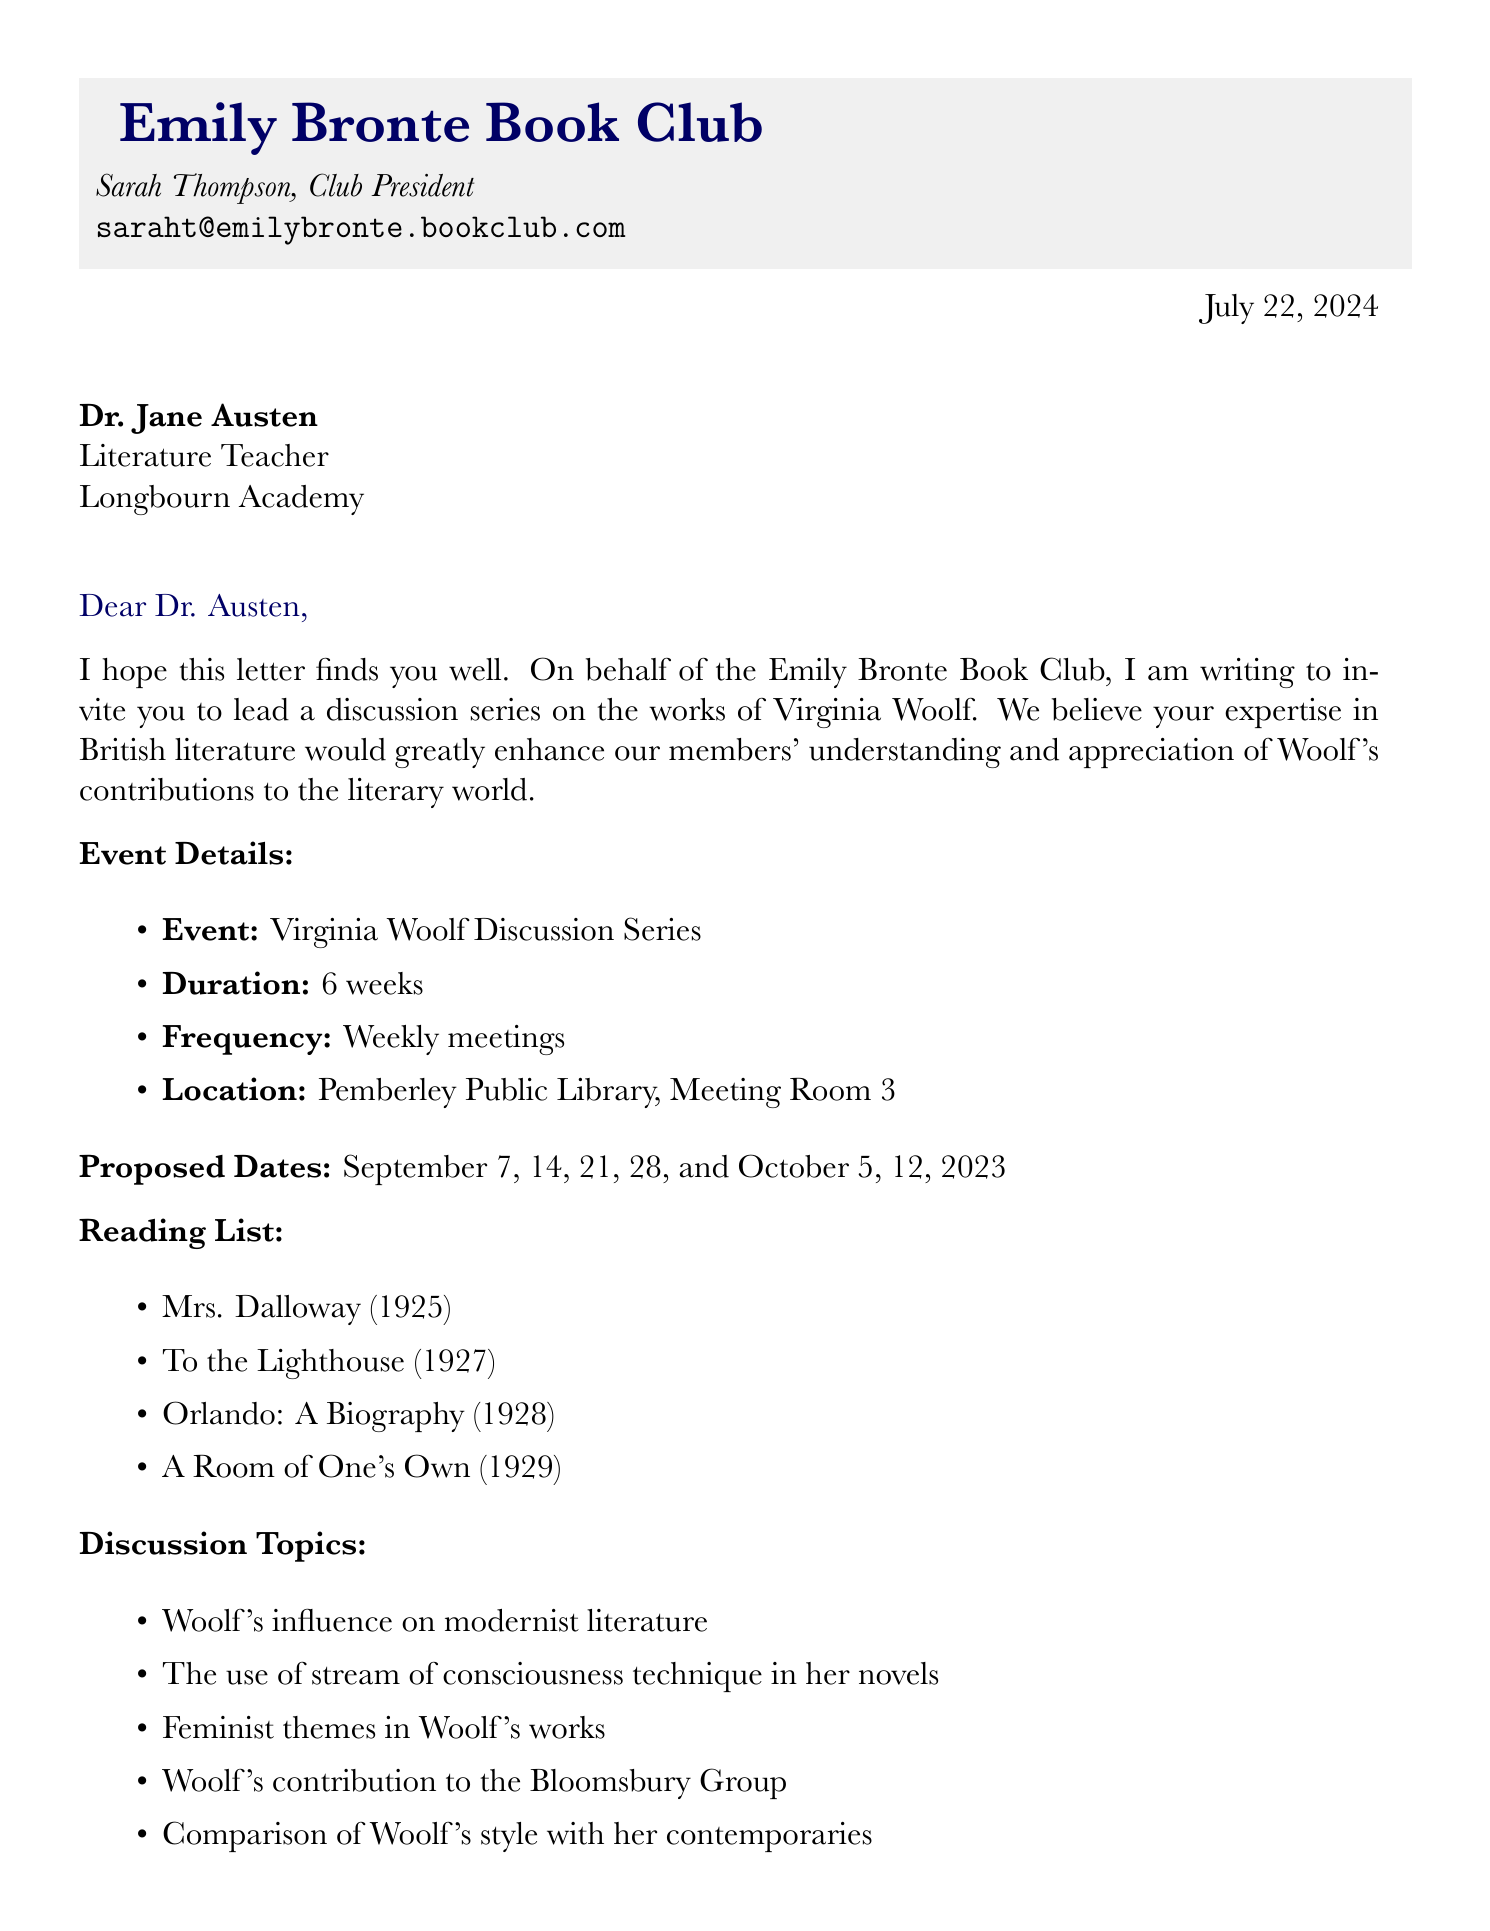What is the name of the book club? The name of the book club is mentioned at the beginning of the document.
Answer: Emily Bronte Book Club Who is the recipient of the letter? The recipient is specified in the address at the beginning of the letter.
Answer: Dr. Jane Austen What is the total duration of the discussion series? The duration is outlined in the event details section of the document.
Answer: 6 weeks On what date does the Virginia Woolf Discussion Series start? The proposed dates indicate the series begins on the first listed date.
Answer: September 7, 2023 Which book was published in 1929? The reading list provides publication years for each book.
Answer: A Room of One's Own What is one of the discussion topics mentioned? The discussion topics are listed in the document.
Answer: Woolf's influence on modernist literature What is the maximum number of members in the book club? The document states the current membership size.
Answer: 25 Who is the Club President? The president's name is provided within the closing section of the letter.
Answer: Sarah Thompson What type of literature does the book club focus on? The club's focus is outlined in the club background section.
Answer: British literature from the 19th and 20th centuries 